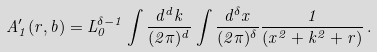Convert formula to latex. <formula><loc_0><loc_0><loc_500><loc_500>A ^ { \prime } _ { 1 } ( r , b ) = L _ { 0 } ^ { \delta - 1 } \int \frac { d ^ { d } k } { ( 2 \pi ) ^ { d } } \int \frac { d ^ { \delta } x } { ( 2 \pi ) ^ { \delta } } \frac { 1 } { ( x ^ { 2 } + k ^ { 2 } + r ) } \, .</formula> 